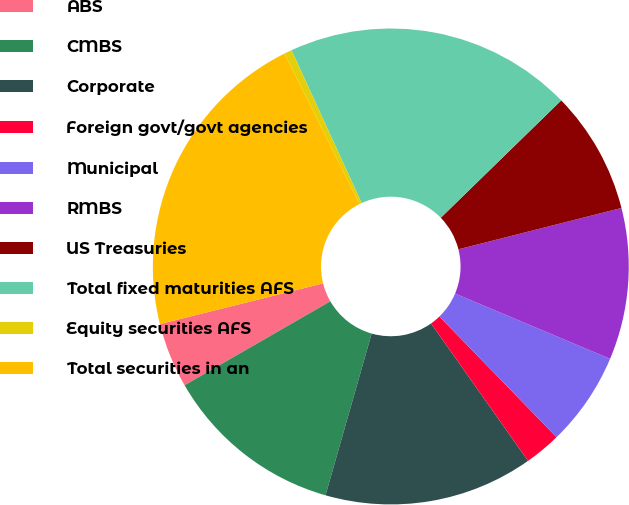Convert chart to OTSL. <chart><loc_0><loc_0><loc_500><loc_500><pie_chart><fcel>ABS<fcel>CMBS<fcel>Corporate<fcel>Foreign govt/govt agencies<fcel>Municipal<fcel>RMBS<fcel>US Treasuries<fcel>Total fixed maturities AFS<fcel>Equity securities AFS<fcel>Total securities in an<nl><fcel>4.43%<fcel>12.26%<fcel>14.21%<fcel>2.48%<fcel>6.39%<fcel>10.3%<fcel>8.34%<fcel>19.56%<fcel>0.52%<fcel>21.52%<nl></chart> 